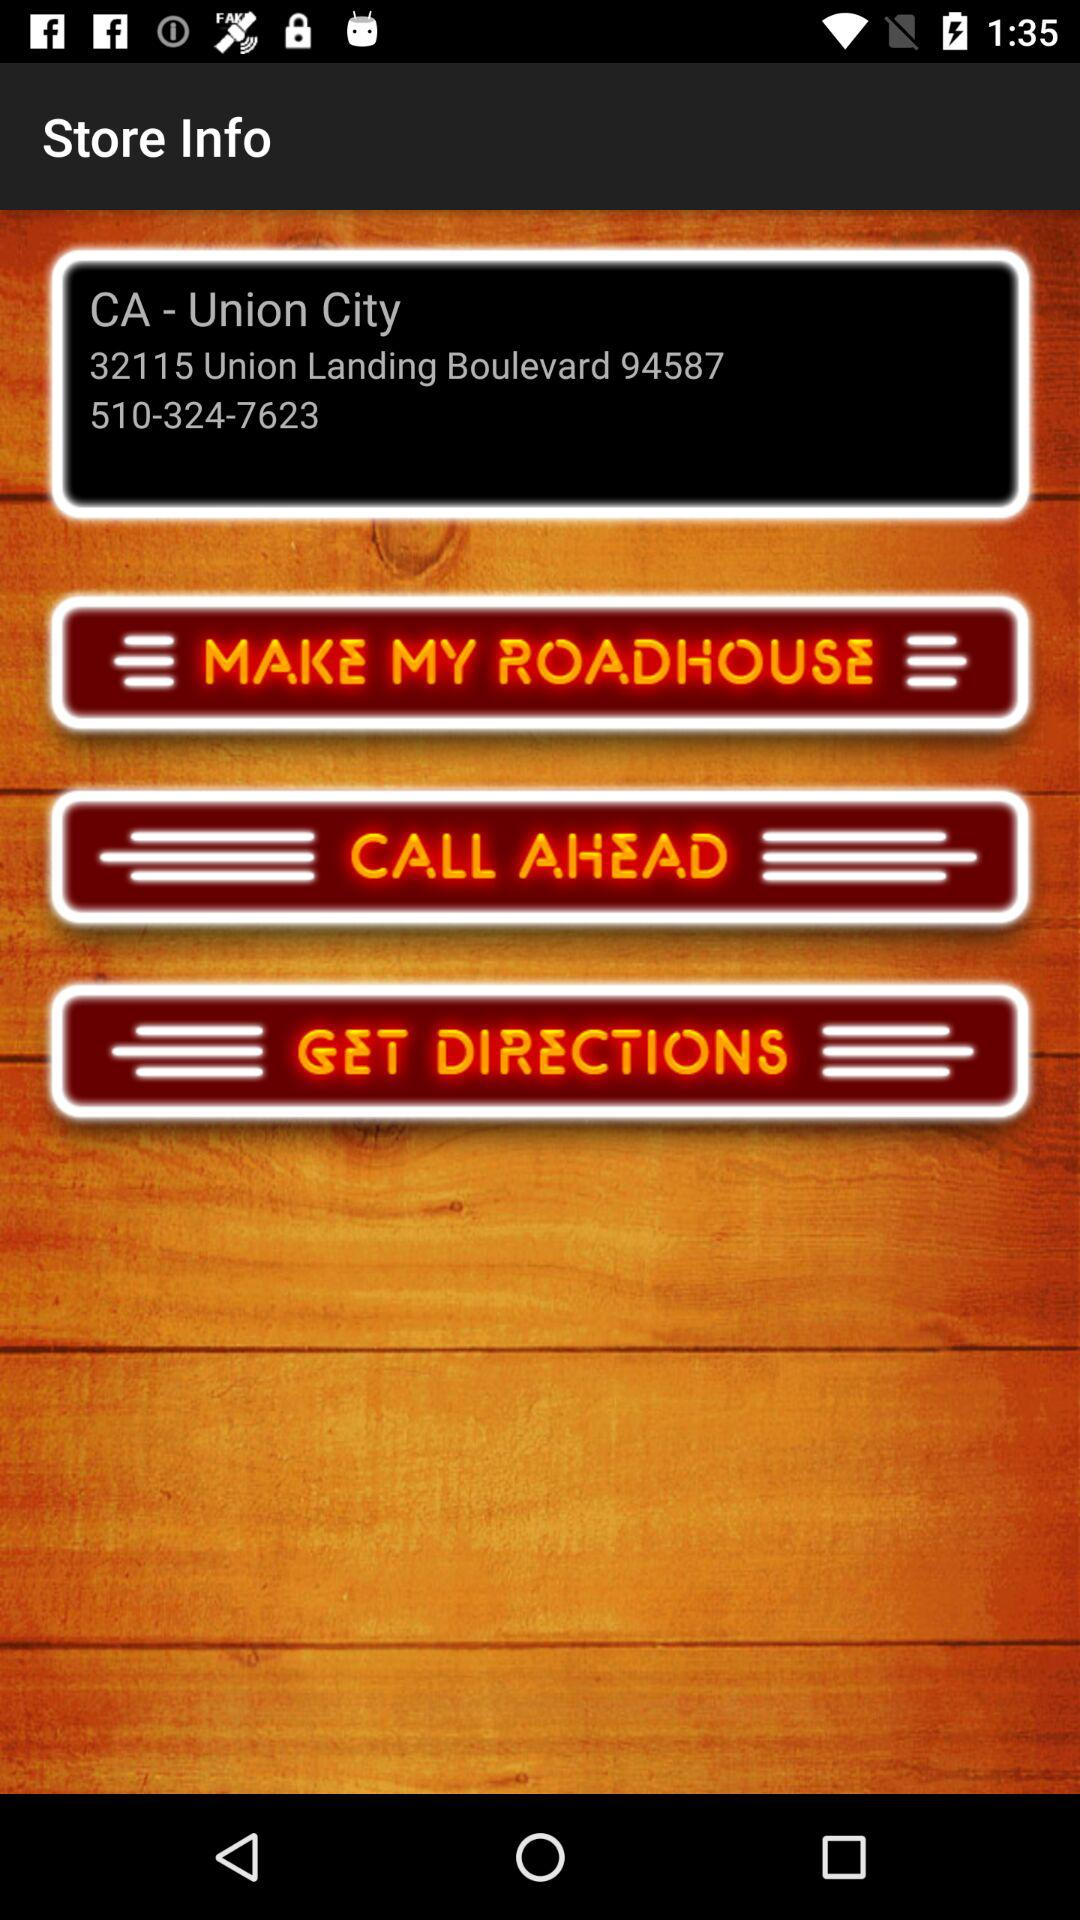What is the store address? The store address is CA-Union City, 32115 Union Landing Boulevard, 94587, 510-324-7623. 